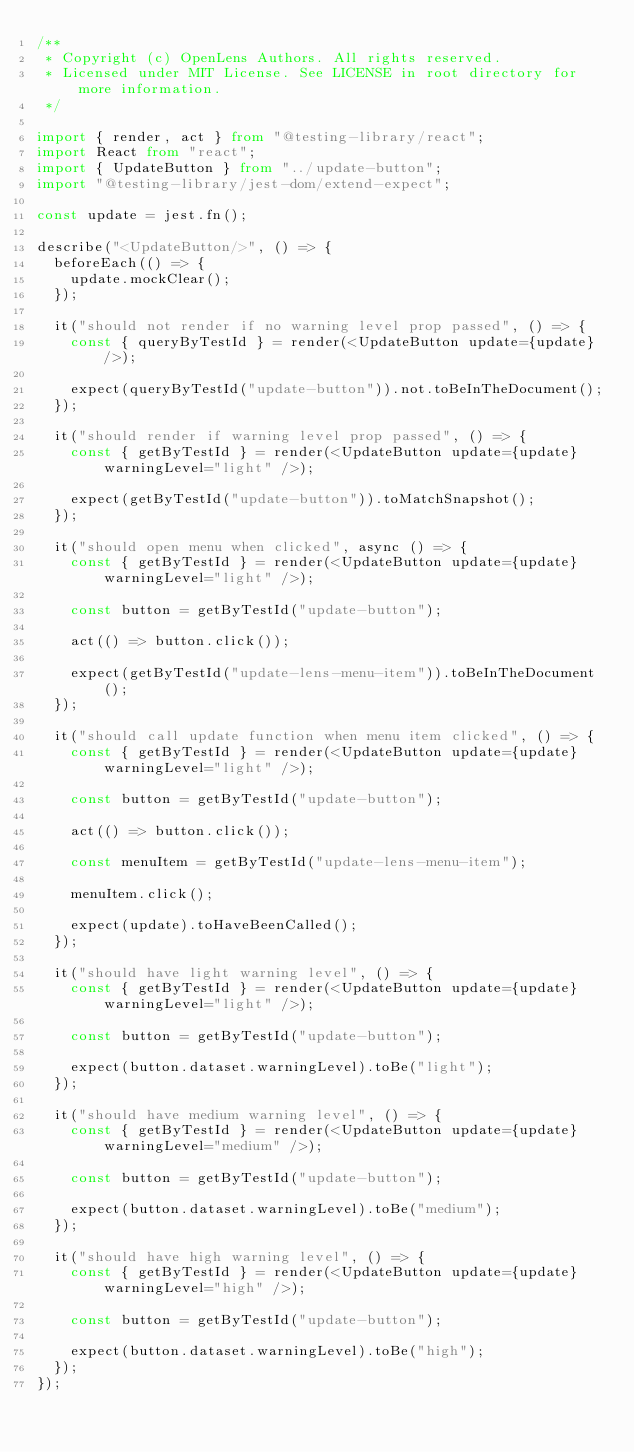<code> <loc_0><loc_0><loc_500><loc_500><_TypeScript_>/**
 * Copyright (c) OpenLens Authors. All rights reserved.
 * Licensed under MIT License. See LICENSE in root directory for more information.
 */

import { render, act } from "@testing-library/react";
import React from "react";
import { UpdateButton } from "../update-button";
import "@testing-library/jest-dom/extend-expect";

const update = jest.fn();

describe("<UpdateButton/>", () => {
  beforeEach(() => {
    update.mockClear();
  });

  it("should not render if no warning level prop passed", () => {
    const { queryByTestId } = render(<UpdateButton update={update} />);

    expect(queryByTestId("update-button")).not.toBeInTheDocument();
  });

  it("should render if warning level prop passed", () => {
    const { getByTestId } = render(<UpdateButton update={update} warningLevel="light" />);

    expect(getByTestId("update-button")).toMatchSnapshot();
  });

  it("should open menu when clicked", async () => {
    const { getByTestId } = render(<UpdateButton update={update} warningLevel="light" />);

    const button = getByTestId("update-button");

    act(() => button.click());

    expect(getByTestId("update-lens-menu-item")).toBeInTheDocument();
  });

  it("should call update function when menu item clicked", () => {
    const { getByTestId } = render(<UpdateButton update={update} warningLevel="light" />);

    const button = getByTestId("update-button");

    act(() => button.click());

    const menuItem = getByTestId("update-lens-menu-item");

    menuItem.click();

    expect(update).toHaveBeenCalled();
  });

  it("should have light warning level", () => {
    const { getByTestId } = render(<UpdateButton update={update} warningLevel="light" />);

    const button = getByTestId("update-button");

    expect(button.dataset.warningLevel).toBe("light");
  });

  it("should have medium warning level", () => {
    const { getByTestId } = render(<UpdateButton update={update} warningLevel="medium" />);

    const button = getByTestId("update-button");

    expect(button.dataset.warningLevel).toBe("medium");
  });

  it("should have high warning level", () => {
    const { getByTestId } = render(<UpdateButton update={update} warningLevel="high" />);

    const button = getByTestId("update-button");

    expect(button.dataset.warningLevel).toBe("high");
  });
});
</code> 